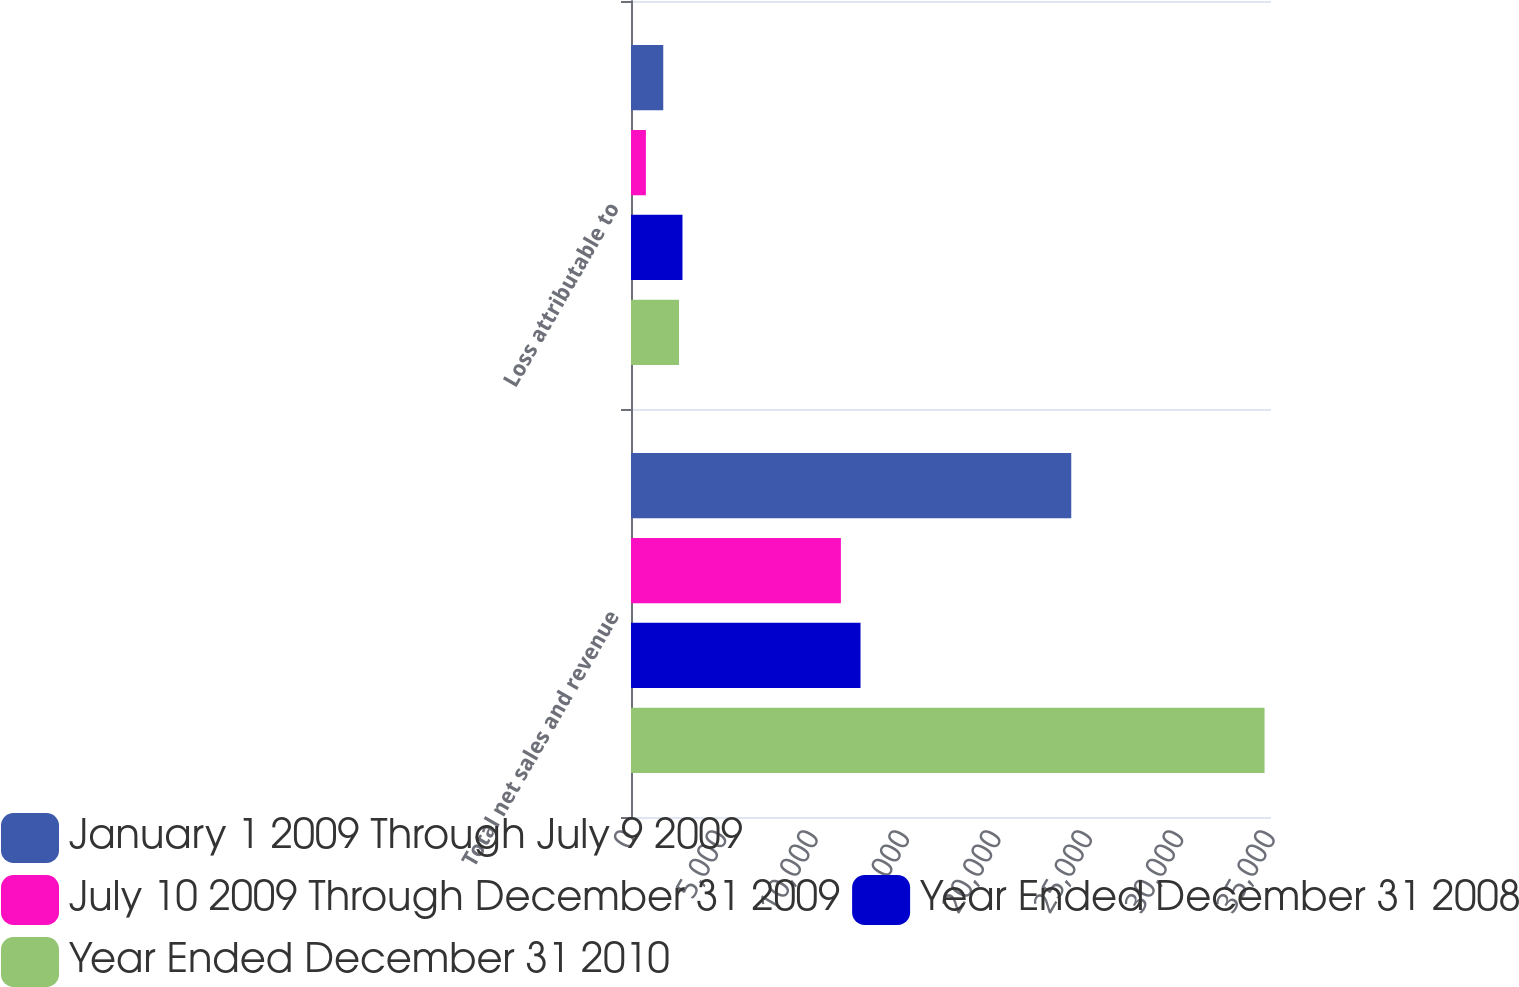Convert chart to OTSL. <chart><loc_0><loc_0><loc_500><loc_500><stacked_bar_chart><ecel><fcel>Total net sales and revenue<fcel>Loss attributable to<nl><fcel>January 1 2009 Through July 9 2009<fcel>24076<fcel>1764<nl><fcel>July 10 2009 Through December 31 2009<fcel>11479<fcel>814<nl><fcel>Year Ended December 31 2008<fcel>12552<fcel>2815<nl><fcel>Year Ended December 31 2010<fcel>34647<fcel>2625<nl></chart> 